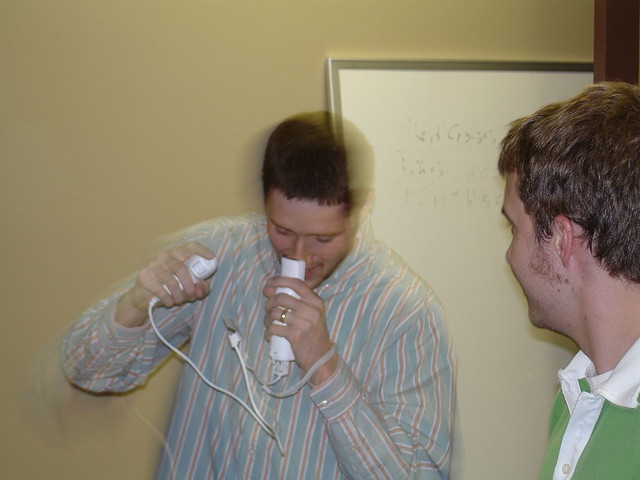Describe the objects in this image and their specific colors. I can see people in olive, darkgray, and gray tones, people in olive, black, gray, and green tones, remote in olive, darkgray, lavender, and lightgray tones, and remote in olive, darkgray, lavender, and gray tones in this image. 